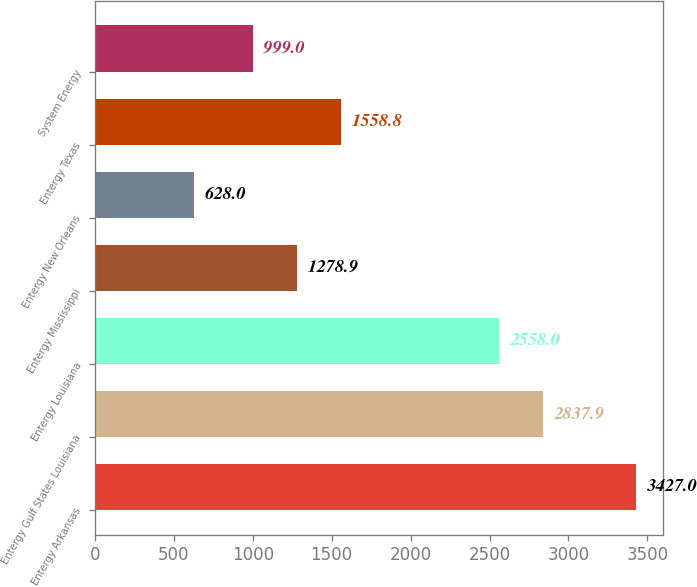<chart> <loc_0><loc_0><loc_500><loc_500><bar_chart><fcel>Entergy Arkansas<fcel>Entergy Gulf States Louisiana<fcel>Entergy Louisiana<fcel>Entergy Mississippi<fcel>Entergy New Orleans<fcel>Entergy Texas<fcel>System Energy<nl><fcel>3427<fcel>2837.9<fcel>2558<fcel>1278.9<fcel>628<fcel>1558.8<fcel>999<nl></chart> 